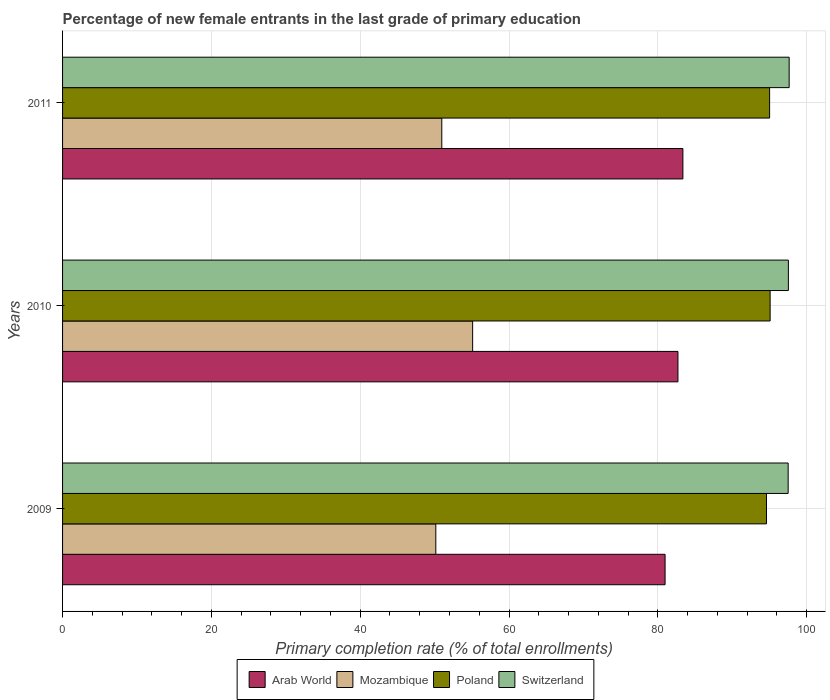Are the number of bars per tick equal to the number of legend labels?
Your answer should be very brief. Yes. How many bars are there on the 1st tick from the bottom?
Offer a terse response. 4. In how many cases, is the number of bars for a given year not equal to the number of legend labels?
Keep it short and to the point. 0. What is the percentage of new female entrants in Arab World in 2011?
Provide a succinct answer. 83.36. Across all years, what is the maximum percentage of new female entrants in Poland?
Ensure brevity in your answer.  95.09. Across all years, what is the minimum percentage of new female entrants in Switzerland?
Your response must be concise. 97.51. What is the total percentage of new female entrants in Poland in the graph?
Give a very brief answer. 284.7. What is the difference between the percentage of new female entrants in Switzerland in 2009 and that in 2010?
Ensure brevity in your answer.  -0.03. What is the difference between the percentage of new female entrants in Mozambique in 2009 and the percentage of new female entrants in Switzerland in 2011?
Your answer should be compact. -47.48. What is the average percentage of new female entrants in Arab World per year?
Your answer should be compact. 82.34. In the year 2009, what is the difference between the percentage of new female entrants in Poland and percentage of new female entrants in Switzerland?
Offer a very short reply. -2.91. What is the ratio of the percentage of new female entrants in Arab World in 2009 to that in 2010?
Your response must be concise. 0.98. Is the percentage of new female entrants in Arab World in 2010 less than that in 2011?
Give a very brief answer. Yes. What is the difference between the highest and the second highest percentage of new female entrants in Poland?
Keep it short and to the point. 0.07. What is the difference between the highest and the lowest percentage of new female entrants in Arab World?
Keep it short and to the point. 2.39. In how many years, is the percentage of new female entrants in Arab World greater than the average percentage of new female entrants in Arab World taken over all years?
Provide a short and direct response. 2. Is it the case that in every year, the sum of the percentage of new female entrants in Mozambique and percentage of new female entrants in Arab World is greater than the sum of percentage of new female entrants in Poland and percentage of new female entrants in Switzerland?
Make the answer very short. No. What does the 3rd bar from the top in 2011 represents?
Offer a terse response. Mozambique. What does the 2nd bar from the bottom in 2010 represents?
Your answer should be compact. Mozambique. Is it the case that in every year, the sum of the percentage of new female entrants in Poland and percentage of new female entrants in Switzerland is greater than the percentage of new female entrants in Mozambique?
Provide a short and direct response. Yes. What is the difference between two consecutive major ticks on the X-axis?
Give a very brief answer. 20. Does the graph contain any zero values?
Make the answer very short. No. How many legend labels are there?
Provide a succinct answer. 4. How are the legend labels stacked?
Give a very brief answer. Horizontal. What is the title of the graph?
Keep it short and to the point. Percentage of new female entrants in the last grade of primary education. Does "Brazil" appear as one of the legend labels in the graph?
Offer a terse response. No. What is the label or title of the X-axis?
Provide a succinct answer. Primary completion rate (% of total enrollments). What is the label or title of the Y-axis?
Your answer should be very brief. Years. What is the Primary completion rate (% of total enrollments) of Arab World in 2009?
Your answer should be very brief. 80.97. What is the Primary completion rate (% of total enrollments) of Mozambique in 2009?
Your response must be concise. 50.16. What is the Primary completion rate (% of total enrollments) in Poland in 2009?
Offer a terse response. 94.6. What is the Primary completion rate (% of total enrollments) of Switzerland in 2009?
Provide a succinct answer. 97.51. What is the Primary completion rate (% of total enrollments) of Arab World in 2010?
Your response must be concise. 82.7. What is the Primary completion rate (% of total enrollments) in Mozambique in 2010?
Your response must be concise. 55.11. What is the Primary completion rate (% of total enrollments) of Poland in 2010?
Your answer should be very brief. 95.09. What is the Primary completion rate (% of total enrollments) in Switzerland in 2010?
Your answer should be very brief. 97.54. What is the Primary completion rate (% of total enrollments) of Arab World in 2011?
Make the answer very short. 83.36. What is the Primary completion rate (% of total enrollments) of Mozambique in 2011?
Keep it short and to the point. 50.96. What is the Primary completion rate (% of total enrollments) of Poland in 2011?
Ensure brevity in your answer.  95.02. What is the Primary completion rate (% of total enrollments) in Switzerland in 2011?
Keep it short and to the point. 97.64. Across all years, what is the maximum Primary completion rate (% of total enrollments) of Arab World?
Ensure brevity in your answer.  83.36. Across all years, what is the maximum Primary completion rate (% of total enrollments) of Mozambique?
Give a very brief answer. 55.11. Across all years, what is the maximum Primary completion rate (% of total enrollments) of Poland?
Your answer should be compact. 95.09. Across all years, what is the maximum Primary completion rate (% of total enrollments) in Switzerland?
Provide a short and direct response. 97.64. Across all years, what is the minimum Primary completion rate (% of total enrollments) in Arab World?
Keep it short and to the point. 80.97. Across all years, what is the minimum Primary completion rate (% of total enrollments) of Mozambique?
Your answer should be compact. 50.16. Across all years, what is the minimum Primary completion rate (% of total enrollments) in Poland?
Your answer should be very brief. 94.6. Across all years, what is the minimum Primary completion rate (% of total enrollments) of Switzerland?
Offer a terse response. 97.51. What is the total Primary completion rate (% of total enrollments) in Arab World in the graph?
Provide a short and direct response. 247.03. What is the total Primary completion rate (% of total enrollments) of Mozambique in the graph?
Offer a very short reply. 156.23. What is the total Primary completion rate (% of total enrollments) of Poland in the graph?
Provide a short and direct response. 284.7. What is the total Primary completion rate (% of total enrollments) of Switzerland in the graph?
Offer a terse response. 292.69. What is the difference between the Primary completion rate (% of total enrollments) in Arab World in 2009 and that in 2010?
Offer a terse response. -1.73. What is the difference between the Primary completion rate (% of total enrollments) in Mozambique in 2009 and that in 2010?
Keep it short and to the point. -4.95. What is the difference between the Primary completion rate (% of total enrollments) in Poland in 2009 and that in 2010?
Your response must be concise. -0.49. What is the difference between the Primary completion rate (% of total enrollments) of Switzerland in 2009 and that in 2010?
Your answer should be very brief. -0.03. What is the difference between the Primary completion rate (% of total enrollments) in Arab World in 2009 and that in 2011?
Your answer should be compact. -2.39. What is the difference between the Primary completion rate (% of total enrollments) in Mozambique in 2009 and that in 2011?
Your answer should be very brief. -0.8. What is the difference between the Primary completion rate (% of total enrollments) in Poland in 2009 and that in 2011?
Your answer should be compact. -0.42. What is the difference between the Primary completion rate (% of total enrollments) of Switzerland in 2009 and that in 2011?
Ensure brevity in your answer.  -0.14. What is the difference between the Primary completion rate (% of total enrollments) of Arab World in 2010 and that in 2011?
Your answer should be very brief. -0.67. What is the difference between the Primary completion rate (% of total enrollments) in Mozambique in 2010 and that in 2011?
Give a very brief answer. 4.14. What is the difference between the Primary completion rate (% of total enrollments) in Poland in 2010 and that in 2011?
Your answer should be very brief. 0.07. What is the difference between the Primary completion rate (% of total enrollments) in Switzerland in 2010 and that in 2011?
Keep it short and to the point. -0.11. What is the difference between the Primary completion rate (% of total enrollments) in Arab World in 2009 and the Primary completion rate (% of total enrollments) in Mozambique in 2010?
Give a very brief answer. 25.86. What is the difference between the Primary completion rate (% of total enrollments) of Arab World in 2009 and the Primary completion rate (% of total enrollments) of Poland in 2010?
Provide a short and direct response. -14.12. What is the difference between the Primary completion rate (% of total enrollments) in Arab World in 2009 and the Primary completion rate (% of total enrollments) in Switzerland in 2010?
Your answer should be compact. -16.57. What is the difference between the Primary completion rate (% of total enrollments) of Mozambique in 2009 and the Primary completion rate (% of total enrollments) of Poland in 2010?
Your answer should be compact. -44.93. What is the difference between the Primary completion rate (% of total enrollments) in Mozambique in 2009 and the Primary completion rate (% of total enrollments) in Switzerland in 2010?
Your answer should be compact. -47.38. What is the difference between the Primary completion rate (% of total enrollments) of Poland in 2009 and the Primary completion rate (% of total enrollments) of Switzerland in 2010?
Your answer should be very brief. -2.94. What is the difference between the Primary completion rate (% of total enrollments) in Arab World in 2009 and the Primary completion rate (% of total enrollments) in Mozambique in 2011?
Make the answer very short. 30.01. What is the difference between the Primary completion rate (% of total enrollments) in Arab World in 2009 and the Primary completion rate (% of total enrollments) in Poland in 2011?
Offer a very short reply. -14.05. What is the difference between the Primary completion rate (% of total enrollments) of Arab World in 2009 and the Primary completion rate (% of total enrollments) of Switzerland in 2011?
Your response must be concise. -16.67. What is the difference between the Primary completion rate (% of total enrollments) in Mozambique in 2009 and the Primary completion rate (% of total enrollments) in Poland in 2011?
Give a very brief answer. -44.86. What is the difference between the Primary completion rate (% of total enrollments) of Mozambique in 2009 and the Primary completion rate (% of total enrollments) of Switzerland in 2011?
Keep it short and to the point. -47.48. What is the difference between the Primary completion rate (% of total enrollments) of Poland in 2009 and the Primary completion rate (% of total enrollments) of Switzerland in 2011?
Offer a terse response. -3.05. What is the difference between the Primary completion rate (% of total enrollments) in Arab World in 2010 and the Primary completion rate (% of total enrollments) in Mozambique in 2011?
Your response must be concise. 31.74. What is the difference between the Primary completion rate (% of total enrollments) of Arab World in 2010 and the Primary completion rate (% of total enrollments) of Poland in 2011?
Provide a short and direct response. -12.32. What is the difference between the Primary completion rate (% of total enrollments) in Arab World in 2010 and the Primary completion rate (% of total enrollments) in Switzerland in 2011?
Your response must be concise. -14.95. What is the difference between the Primary completion rate (% of total enrollments) in Mozambique in 2010 and the Primary completion rate (% of total enrollments) in Poland in 2011?
Give a very brief answer. -39.91. What is the difference between the Primary completion rate (% of total enrollments) of Mozambique in 2010 and the Primary completion rate (% of total enrollments) of Switzerland in 2011?
Offer a terse response. -42.54. What is the difference between the Primary completion rate (% of total enrollments) in Poland in 2010 and the Primary completion rate (% of total enrollments) in Switzerland in 2011?
Provide a short and direct response. -2.56. What is the average Primary completion rate (% of total enrollments) of Arab World per year?
Provide a short and direct response. 82.34. What is the average Primary completion rate (% of total enrollments) in Mozambique per year?
Your answer should be compact. 52.08. What is the average Primary completion rate (% of total enrollments) in Poland per year?
Provide a succinct answer. 94.9. What is the average Primary completion rate (% of total enrollments) of Switzerland per year?
Make the answer very short. 97.56. In the year 2009, what is the difference between the Primary completion rate (% of total enrollments) in Arab World and Primary completion rate (% of total enrollments) in Mozambique?
Your answer should be very brief. 30.81. In the year 2009, what is the difference between the Primary completion rate (% of total enrollments) in Arab World and Primary completion rate (% of total enrollments) in Poland?
Make the answer very short. -13.63. In the year 2009, what is the difference between the Primary completion rate (% of total enrollments) of Arab World and Primary completion rate (% of total enrollments) of Switzerland?
Provide a short and direct response. -16.54. In the year 2009, what is the difference between the Primary completion rate (% of total enrollments) of Mozambique and Primary completion rate (% of total enrollments) of Poland?
Provide a succinct answer. -44.44. In the year 2009, what is the difference between the Primary completion rate (% of total enrollments) of Mozambique and Primary completion rate (% of total enrollments) of Switzerland?
Offer a very short reply. -47.35. In the year 2009, what is the difference between the Primary completion rate (% of total enrollments) in Poland and Primary completion rate (% of total enrollments) in Switzerland?
Offer a very short reply. -2.91. In the year 2010, what is the difference between the Primary completion rate (% of total enrollments) in Arab World and Primary completion rate (% of total enrollments) in Mozambique?
Make the answer very short. 27.59. In the year 2010, what is the difference between the Primary completion rate (% of total enrollments) in Arab World and Primary completion rate (% of total enrollments) in Poland?
Offer a terse response. -12.39. In the year 2010, what is the difference between the Primary completion rate (% of total enrollments) of Arab World and Primary completion rate (% of total enrollments) of Switzerland?
Your answer should be compact. -14.84. In the year 2010, what is the difference between the Primary completion rate (% of total enrollments) of Mozambique and Primary completion rate (% of total enrollments) of Poland?
Provide a succinct answer. -39.98. In the year 2010, what is the difference between the Primary completion rate (% of total enrollments) of Mozambique and Primary completion rate (% of total enrollments) of Switzerland?
Provide a short and direct response. -42.43. In the year 2010, what is the difference between the Primary completion rate (% of total enrollments) of Poland and Primary completion rate (% of total enrollments) of Switzerland?
Keep it short and to the point. -2.45. In the year 2011, what is the difference between the Primary completion rate (% of total enrollments) in Arab World and Primary completion rate (% of total enrollments) in Mozambique?
Your answer should be very brief. 32.4. In the year 2011, what is the difference between the Primary completion rate (% of total enrollments) in Arab World and Primary completion rate (% of total enrollments) in Poland?
Offer a terse response. -11.65. In the year 2011, what is the difference between the Primary completion rate (% of total enrollments) in Arab World and Primary completion rate (% of total enrollments) in Switzerland?
Offer a terse response. -14.28. In the year 2011, what is the difference between the Primary completion rate (% of total enrollments) in Mozambique and Primary completion rate (% of total enrollments) in Poland?
Offer a terse response. -44.05. In the year 2011, what is the difference between the Primary completion rate (% of total enrollments) of Mozambique and Primary completion rate (% of total enrollments) of Switzerland?
Ensure brevity in your answer.  -46.68. In the year 2011, what is the difference between the Primary completion rate (% of total enrollments) in Poland and Primary completion rate (% of total enrollments) in Switzerland?
Offer a very short reply. -2.63. What is the ratio of the Primary completion rate (% of total enrollments) of Arab World in 2009 to that in 2010?
Keep it short and to the point. 0.98. What is the ratio of the Primary completion rate (% of total enrollments) in Mozambique in 2009 to that in 2010?
Ensure brevity in your answer.  0.91. What is the ratio of the Primary completion rate (% of total enrollments) of Poland in 2009 to that in 2010?
Ensure brevity in your answer.  0.99. What is the ratio of the Primary completion rate (% of total enrollments) of Switzerland in 2009 to that in 2010?
Offer a terse response. 1. What is the ratio of the Primary completion rate (% of total enrollments) in Arab World in 2009 to that in 2011?
Offer a very short reply. 0.97. What is the ratio of the Primary completion rate (% of total enrollments) in Mozambique in 2009 to that in 2011?
Make the answer very short. 0.98. What is the ratio of the Primary completion rate (% of total enrollments) of Switzerland in 2009 to that in 2011?
Give a very brief answer. 1. What is the ratio of the Primary completion rate (% of total enrollments) of Mozambique in 2010 to that in 2011?
Ensure brevity in your answer.  1.08. What is the ratio of the Primary completion rate (% of total enrollments) of Switzerland in 2010 to that in 2011?
Ensure brevity in your answer.  1. What is the difference between the highest and the second highest Primary completion rate (% of total enrollments) of Arab World?
Your answer should be very brief. 0.67. What is the difference between the highest and the second highest Primary completion rate (% of total enrollments) of Mozambique?
Ensure brevity in your answer.  4.14. What is the difference between the highest and the second highest Primary completion rate (% of total enrollments) of Poland?
Your answer should be compact. 0.07. What is the difference between the highest and the second highest Primary completion rate (% of total enrollments) of Switzerland?
Offer a terse response. 0.11. What is the difference between the highest and the lowest Primary completion rate (% of total enrollments) of Arab World?
Give a very brief answer. 2.39. What is the difference between the highest and the lowest Primary completion rate (% of total enrollments) of Mozambique?
Offer a very short reply. 4.95. What is the difference between the highest and the lowest Primary completion rate (% of total enrollments) in Poland?
Your response must be concise. 0.49. What is the difference between the highest and the lowest Primary completion rate (% of total enrollments) of Switzerland?
Your answer should be very brief. 0.14. 